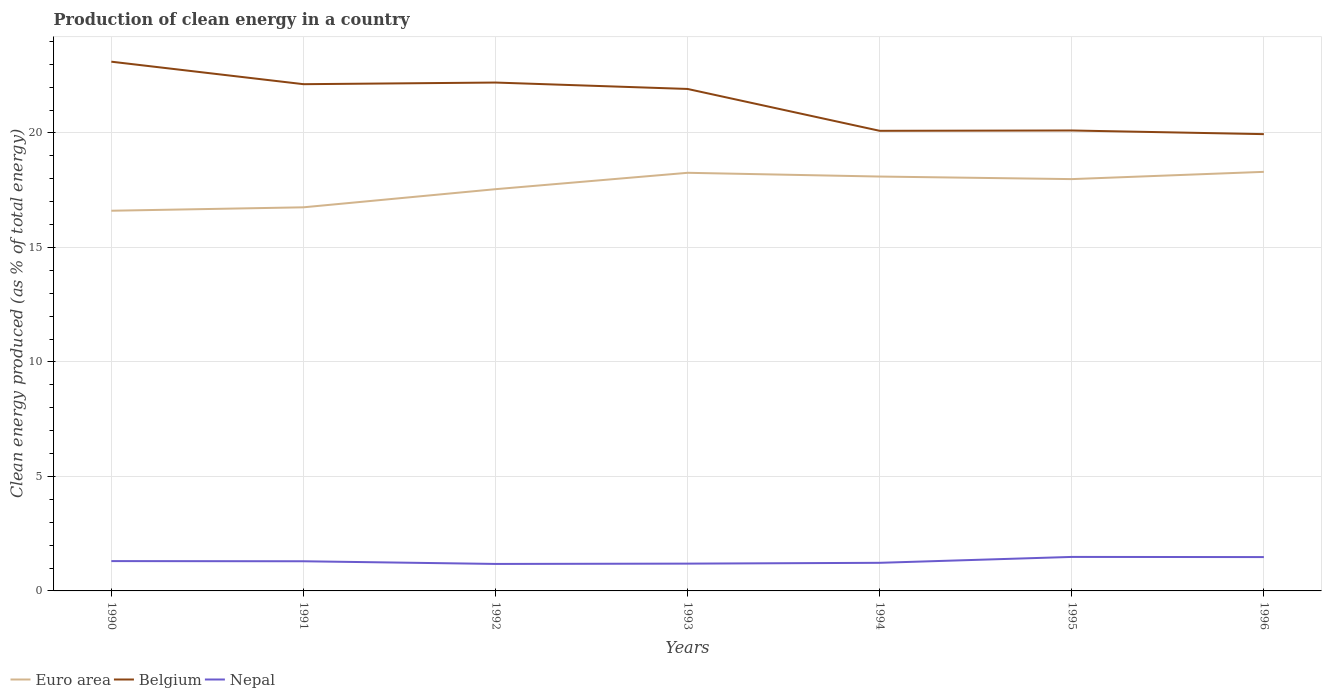Is the number of lines equal to the number of legend labels?
Your answer should be very brief. Yes. Across all years, what is the maximum percentage of clean energy produced in Euro area?
Offer a very short reply. 16.6. What is the total percentage of clean energy produced in Nepal in the graph?
Provide a succinct answer. -0.3. What is the difference between the highest and the second highest percentage of clean energy produced in Belgium?
Offer a very short reply. 3.16. How many years are there in the graph?
Provide a succinct answer. 7. What is the difference between two consecutive major ticks on the Y-axis?
Your answer should be very brief. 5. Does the graph contain grids?
Keep it short and to the point. Yes. Where does the legend appear in the graph?
Ensure brevity in your answer.  Bottom left. How are the legend labels stacked?
Your answer should be compact. Horizontal. What is the title of the graph?
Give a very brief answer. Production of clean energy in a country. What is the label or title of the Y-axis?
Make the answer very short. Clean energy produced (as % of total energy). What is the Clean energy produced (as % of total energy) in Euro area in 1990?
Keep it short and to the point. 16.6. What is the Clean energy produced (as % of total energy) in Belgium in 1990?
Provide a short and direct response. 23.11. What is the Clean energy produced (as % of total energy) in Nepal in 1990?
Offer a terse response. 1.3. What is the Clean energy produced (as % of total energy) in Euro area in 1991?
Keep it short and to the point. 16.75. What is the Clean energy produced (as % of total energy) of Belgium in 1991?
Ensure brevity in your answer.  22.13. What is the Clean energy produced (as % of total energy) of Nepal in 1991?
Provide a short and direct response. 1.3. What is the Clean energy produced (as % of total energy) in Euro area in 1992?
Provide a short and direct response. 17.54. What is the Clean energy produced (as % of total energy) in Belgium in 1992?
Provide a succinct answer. 22.2. What is the Clean energy produced (as % of total energy) in Nepal in 1992?
Keep it short and to the point. 1.18. What is the Clean energy produced (as % of total energy) in Euro area in 1993?
Your response must be concise. 18.26. What is the Clean energy produced (as % of total energy) in Belgium in 1993?
Your answer should be very brief. 21.92. What is the Clean energy produced (as % of total energy) in Nepal in 1993?
Provide a succinct answer. 1.19. What is the Clean energy produced (as % of total energy) in Euro area in 1994?
Make the answer very short. 18.1. What is the Clean energy produced (as % of total energy) of Belgium in 1994?
Your answer should be very brief. 20.09. What is the Clean energy produced (as % of total energy) of Nepal in 1994?
Your response must be concise. 1.23. What is the Clean energy produced (as % of total energy) of Euro area in 1995?
Your answer should be compact. 17.98. What is the Clean energy produced (as % of total energy) of Belgium in 1995?
Offer a very short reply. 20.11. What is the Clean energy produced (as % of total energy) in Nepal in 1995?
Your answer should be compact. 1.49. What is the Clean energy produced (as % of total energy) of Euro area in 1996?
Give a very brief answer. 18.3. What is the Clean energy produced (as % of total energy) of Belgium in 1996?
Offer a very short reply. 19.95. What is the Clean energy produced (as % of total energy) in Nepal in 1996?
Provide a short and direct response. 1.48. Across all years, what is the maximum Clean energy produced (as % of total energy) of Euro area?
Make the answer very short. 18.3. Across all years, what is the maximum Clean energy produced (as % of total energy) in Belgium?
Give a very brief answer. 23.11. Across all years, what is the maximum Clean energy produced (as % of total energy) of Nepal?
Your response must be concise. 1.49. Across all years, what is the minimum Clean energy produced (as % of total energy) of Euro area?
Keep it short and to the point. 16.6. Across all years, what is the minimum Clean energy produced (as % of total energy) of Belgium?
Keep it short and to the point. 19.95. Across all years, what is the minimum Clean energy produced (as % of total energy) in Nepal?
Make the answer very short. 1.18. What is the total Clean energy produced (as % of total energy) in Euro area in the graph?
Keep it short and to the point. 123.54. What is the total Clean energy produced (as % of total energy) in Belgium in the graph?
Ensure brevity in your answer.  149.51. What is the total Clean energy produced (as % of total energy) in Nepal in the graph?
Offer a very short reply. 9.16. What is the difference between the Clean energy produced (as % of total energy) in Euro area in 1990 and that in 1991?
Offer a terse response. -0.15. What is the difference between the Clean energy produced (as % of total energy) in Belgium in 1990 and that in 1991?
Ensure brevity in your answer.  0.98. What is the difference between the Clean energy produced (as % of total energy) of Nepal in 1990 and that in 1991?
Your answer should be very brief. 0.01. What is the difference between the Clean energy produced (as % of total energy) of Euro area in 1990 and that in 1992?
Offer a terse response. -0.94. What is the difference between the Clean energy produced (as % of total energy) in Belgium in 1990 and that in 1992?
Make the answer very short. 0.91. What is the difference between the Clean energy produced (as % of total energy) in Nepal in 1990 and that in 1992?
Your response must be concise. 0.12. What is the difference between the Clean energy produced (as % of total energy) in Euro area in 1990 and that in 1993?
Provide a short and direct response. -1.66. What is the difference between the Clean energy produced (as % of total energy) of Belgium in 1990 and that in 1993?
Offer a very short reply. 1.19. What is the difference between the Clean energy produced (as % of total energy) in Nepal in 1990 and that in 1993?
Your answer should be very brief. 0.11. What is the difference between the Clean energy produced (as % of total energy) of Euro area in 1990 and that in 1994?
Make the answer very short. -1.49. What is the difference between the Clean energy produced (as % of total energy) in Belgium in 1990 and that in 1994?
Your answer should be very brief. 3.02. What is the difference between the Clean energy produced (as % of total energy) of Nepal in 1990 and that in 1994?
Provide a succinct answer. 0.07. What is the difference between the Clean energy produced (as % of total energy) in Euro area in 1990 and that in 1995?
Provide a succinct answer. -1.38. What is the difference between the Clean energy produced (as % of total energy) of Belgium in 1990 and that in 1995?
Keep it short and to the point. 3. What is the difference between the Clean energy produced (as % of total energy) in Nepal in 1990 and that in 1995?
Your answer should be very brief. -0.18. What is the difference between the Clean energy produced (as % of total energy) of Euro area in 1990 and that in 1996?
Give a very brief answer. -1.7. What is the difference between the Clean energy produced (as % of total energy) of Belgium in 1990 and that in 1996?
Ensure brevity in your answer.  3.16. What is the difference between the Clean energy produced (as % of total energy) of Nepal in 1990 and that in 1996?
Ensure brevity in your answer.  -0.17. What is the difference between the Clean energy produced (as % of total energy) of Euro area in 1991 and that in 1992?
Give a very brief answer. -0.79. What is the difference between the Clean energy produced (as % of total energy) in Belgium in 1991 and that in 1992?
Keep it short and to the point. -0.07. What is the difference between the Clean energy produced (as % of total energy) in Nepal in 1991 and that in 1992?
Ensure brevity in your answer.  0.12. What is the difference between the Clean energy produced (as % of total energy) of Euro area in 1991 and that in 1993?
Your response must be concise. -1.51. What is the difference between the Clean energy produced (as % of total energy) in Belgium in 1991 and that in 1993?
Your response must be concise. 0.21. What is the difference between the Clean energy produced (as % of total energy) in Nepal in 1991 and that in 1993?
Provide a succinct answer. 0.1. What is the difference between the Clean energy produced (as % of total energy) in Euro area in 1991 and that in 1994?
Your answer should be compact. -1.34. What is the difference between the Clean energy produced (as % of total energy) in Belgium in 1991 and that in 1994?
Give a very brief answer. 2.04. What is the difference between the Clean energy produced (as % of total energy) in Nepal in 1991 and that in 1994?
Give a very brief answer. 0.07. What is the difference between the Clean energy produced (as % of total energy) in Euro area in 1991 and that in 1995?
Make the answer very short. -1.23. What is the difference between the Clean energy produced (as % of total energy) in Belgium in 1991 and that in 1995?
Keep it short and to the point. 2.02. What is the difference between the Clean energy produced (as % of total energy) of Nepal in 1991 and that in 1995?
Provide a short and direct response. -0.19. What is the difference between the Clean energy produced (as % of total energy) of Euro area in 1991 and that in 1996?
Give a very brief answer. -1.55. What is the difference between the Clean energy produced (as % of total energy) of Belgium in 1991 and that in 1996?
Provide a succinct answer. 2.18. What is the difference between the Clean energy produced (as % of total energy) in Nepal in 1991 and that in 1996?
Give a very brief answer. -0.18. What is the difference between the Clean energy produced (as % of total energy) of Euro area in 1992 and that in 1993?
Offer a very short reply. -0.72. What is the difference between the Clean energy produced (as % of total energy) of Belgium in 1992 and that in 1993?
Offer a terse response. 0.28. What is the difference between the Clean energy produced (as % of total energy) of Nepal in 1992 and that in 1993?
Provide a short and direct response. -0.01. What is the difference between the Clean energy produced (as % of total energy) of Euro area in 1992 and that in 1994?
Offer a terse response. -0.55. What is the difference between the Clean energy produced (as % of total energy) in Belgium in 1992 and that in 1994?
Your answer should be very brief. 2.11. What is the difference between the Clean energy produced (as % of total energy) in Nepal in 1992 and that in 1994?
Your response must be concise. -0.05. What is the difference between the Clean energy produced (as % of total energy) of Euro area in 1992 and that in 1995?
Provide a succinct answer. -0.44. What is the difference between the Clean energy produced (as % of total energy) in Belgium in 1992 and that in 1995?
Ensure brevity in your answer.  2.09. What is the difference between the Clean energy produced (as % of total energy) of Nepal in 1992 and that in 1995?
Offer a very short reply. -0.31. What is the difference between the Clean energy produced (as % of total energy) in Euro area in 1992 and that in 1996?
Give a very brief answer. -0.76. What is the difference between the Clean energy produced (as % of total energy) in Belgium in 1992 and that in 1996?
Offer a very short reply. 2.25. What is the difference between the Clean energy produced (as % of total energy) in Nepal in 1992 and that in 1996?
Provide a succinct answer. -0.3. What is the difference between the Clean energy produced (as % of total energy) in Euro area in 1993 and that in 1994?
Your response must be concise. 0.16. What is the difference between the Clean energy produced (as % of total energy) in Belgium in 1993 and that in 1994?
Your answer should be very brief. 1.83. What is the difference between the Clean energy produced (as % of total energy) of Nepal in 1993 and that in 1994?
Your response must be concise. -0.04. What is the difference between the Clean energy produced (as % of total energy) of Euro area in 1993 and that in 1995?
Your answer should be very brief. 0.28. What is the difference between the Clean energy produced (as % of total energy) in Belgium in 1993 and that in 1995?
Your answer should be compact. 1.81. What is the difference between the Clean energy produced (as % of total energy) of Nepal in 1993 and that in 1995?
Offer a very short reply. -0.29. What is the difference between the Clean energy produced (as % of total energy) in Euro area in 1993 and that in 1996?
Provide a succinct answer. -0.04. What is the difference between the Clean energy produced (as % of total energy) in Belgium in 1993 and that in 1996?
Ensure brevity in your answer.  1.97. What is the difference between the Clean energy produced (as % of total energy) of Nepal in 1993 and that in 1996?
Provide a short and direct response. -0.29. What is the difference between the Clean energy produced (as % of total energy) in Euro area in 1994 and that in 1995?
Ensure brevity in your answer.  0.11. What is the difference between the Clean energy produced (as % of total energy) of Belgium in 1994 and that in 1995?
Offer a terse response. -0.01. What is the difference between the Clean energy produced (as % of total energy) in Nepal in 1994 and that in 1995?
Ensure brevity in your answer.  -0.26. What is the difference between the Clean energy produced (as % of total energy) of Euro area in 1994 and that in 1996?
Keep it short and to the point. -0.21. What is the difference between the Clean energy produced (as % of total energy) in Belgium in 1994 and that in 1996?
Offer a very short reply. 0.14. What is the difference between the Clean energy produced (as % of total energy) of Nepal in 1994 and that in 1996?
Provide a succinct answer. -0.25. What is the difference between the Clean energy produced (as % of total energy) of Euro area in 1995 and that in 1996?
Provide a short and direct response. -0.32. What is the difference between the Clean energy produced (as % of total energy) in Belgium in 1995 and that in 1996?
Give a very brief answer. 0.16. What is the difference between the Clean energy produced (as % of total energy) of Nepal in 1995 and that in 1996?
Your answer should be compact. 0.01. What is the difference between the Clean energy produced (as % of total energy) of Euro area in 1990 and the Clean energy produced (as % of total energy) of Belgium in 1991?
Provide a succinct answer. -5.53. What is the difference between the Clean energy produced (as % of total energy) of Euro area in 1990 and the Clean energy produced (as % of total energy) of Nepal in 1991?
Offer a very short reply. 15.31. What is the difference between the Clean energy produced (as % of total energy) in Belgium in 1990 and the Clean energy produced (as % of total energy) in Nepal in 1991?
Offer a terse response. 21.82. What is the difference between the Clean energy produced (as % of total energy) in Euro area in 1990 and the Clean energy produced (as % of total energy) in Belgium in 1992?
Offer a terse response. -5.6. What is the difference between the Clean energy produced (as % of total energy) in Euro area in 1990 and the Clean energy produced (as % of total energy) in Nepal in 1992?
Your answer should be compact. 15.42. What is the difference between the Clean energy produced (as % of total energy) of Belgium in 1990 and the Clean energy produced (as % of total energy) of Nepal in 1992?
Keep it short and to the point. 21.93. What is the difference between the Clean energy produced (as % of total energy) of Euro area in 1990 and the Clean energy produced (as % of total energy) of Belgium in 1993?
Your answer should be compact. -5.32. What is the difference between the Clean energy produced (as % of total energy) in Euro area in 1990 and the Clean energy produced (as % of total energy) in Nepal in 1993?
Keep it short and to the point. 15.41. What is the difference between the Clean energy produced (as % of total energy) of Belgium in 1990 and the Clean energy produced (as % of total energy) of Nepal in 1993?
Ensure brevity in your answer.  21.92. What is the difference between the Clean energy produced (as % of total energy) of Euro area in 1990 and the Clean energy produced (as % of total energy) of Belgium in 1994?
Keep it short and to the point. -3.49. What is the difference between the Clean energy produced (as % of total energy) of Euro area in 1990 and the Clean energy produced (as % of total energy) of Nepal in 1994?
Offer a terse response. 15.38. What is the difference between the Clean energy produced (as % of total energy) of Belgium in 1990 and the Clean energy produced (as % of total energy) of Nepal in 1994?
Keep it short and to the point. 21.88. What is the difference between the Clean energy produced (as % of total energy) of Euro area in 1990 and the Clean energy produced (as % of total energy) of Belgium in 1995?
Give a very brief answer. -3.5. What is the difference between the Clean energy produced (as % of total energy) of Euro area in 1990 and the Clean energy produced (as % of total energy) of Nepal in 1995?
Ensure brevity in your answer.  15.12. What is the difference between the Clean energy produced (as % of total energy) of Belgium in 1990 and the Clean energy produced (as % of total energy) of Nepal in 1995?
Ensure brevity in your answer.  21.63. What is the difference between the Clean energy produced (as % of total energy) of Euro area in 1990 and the Clean energy produced (as % of total energy) of Belgium in 1996?
Provide a succinct answer. -3.34. What is the difference between the Clean energy produced (as % of total energy) in Euro area in 1990 and the Clean energy produced (as % of total energy) in Nepal in 1996?
Provide a succinct answer. 15.13. What is the difference between the Clean energy produced (as % of total energy) in Belgium in 1990 and the Clean energy produced (as % of total energy) in Nepal in 1996?
Give a very brief answer. 21.63. What is the difference between the Clean energy produced (as % of total energy) in Euro area in 1991 and the Clean energy produced (as % of total energy) in Belgium in 1992?
Make the answer very short. -5.45. What is the difference between the Clean energy produced (as % of total energy) of Euro area in 1991 and the Clean energy produced (as % of total energy) of Nepal in 1992?
Ensure brevity in your answer.  15.57. What is the difference between the Clean energy produced (as % of total energy) of Belgium in 1991 and the Clean energy produced (as % of total energy) of Nepal in 1992?
Provide a short and direct response. 20.95. What is the difference between the Clean energy produced (as % of total energy) of Euro area in 1991 and the Clean energy produced (as % of total energy) of Belgium in 1993?
Your answer should be compact. -5.17. What is the difference between the Clean energy produced (as % of total energy) in Euro area in 1991 and the Clean energy produced (as % of total energy) in Nepal in 1993?
Give a very brief answer. 15.56. What is the difference between the Clean energy produced (as % of total energy) in Belgium in 1991 and the Clean energy produced (as % of total energy) in Nepal in 1993?
Offer a terse response. 20.94. What is the difference between the Clean energy produced (as % of total energy) of Euro area in 1991 and the Clean energy produced (as % of total energy) of Belgium in 1994?
Your answer should be very brief. -3.34. What is the difference between the Clean energy produced (as % of total energy) of Euro area in 1991 and the Clean energy produced (as % of total energy) of Nepal in 1994?
Make the answer very short. 15.52. What is the difference between the Clean energy produced (as % of total energy) in Belgium in 1991 and the Clean energy produced (as % of total energy) in Nepal in 1994?
Provide a short and direct response. 20.9. What is the difference between the Clean energy produced (as % of total energy) of Euro area in 1991 and the Clean energy produced (as % of total energy) of Belgium in 1995?
Provide a short and direct response. -3.36. What is the difference between the Clean energy produced (as % of total energy) of Euro area in 1991 and the Clean energy produced (as % of total energy) of Nepal in 1995?
Your answer should be compact. 15.27. What is the difference between the Clean energy produced (as % of total energy) in Belgium in 1991 and the Clean energy produced (as % of total energy) in Nepal in 1995?
Your answer should be very brief. 20.64. What is the difference between the Clean energy produced (as % of total energy) in Euro area in 1991 and the Clean energy produced (as % of total energy) in Belgium in 1996?
Make the answer very short. -3.2. What is the difference between the Clean energy produced (as % of total energy) in Euro area in 1991 and the Clean energy produced (as % of total energy) in Nepal in 1996?
Give a very brief answer. 15.27. What is the difference between the Clean energy produced (as % of total energy) in Belgium in 1991 and the Clean energy produced (as % of total energy) in Nepal in 1996?
Provide a short and direct response. 20.65. What is the difference between the Clean energy produced (as % of total energy) of Euro area in 1992 and the Clean energy produced (as % of total energy) of Belgium in 1993?
Offer a very short reply. -4.38. What is the difference between the Clean energy produced (as % of total energy) of Euro area in 1992 and the Clean energy produced (as % of total energy) of Nepal in 1993?
Ensure brevity in your answer.  16.35. What is the difference between the Clean energy produced (as % of total energy) in Belgium in 1992 and the Clean energy produced (as % of total energy) in Nepal in 1993?
Provide a short and direct response. 21.01. What is the difference between the Clean energy produced (as % of total energy) of Euro area in 1992 and the Clean energy produced (as % of total energy) of Belgium in 1994?
Provide a short and direct response. -2.55. What is the difference between the Clean energy produced (as % of total energy) of Euro area in 1992 and the Clean energy produced (as % of total energy) of Nepal in 1994?
Your answer should be very brief. 16.32. What is the difference between the Clean energy produced (as % of total energy) in Belgium in 1992 and the Clean energy produced (as % of total energy) in Nepal in 1994?
Ensure brevity in your answer.  20.97. What is the difference between the Clean energy produced (as % of total energy) in Euro area in 1992 and the Clean energy produced (as % of total energy) in Belgium in 1995?
Your answer should be very brief. -2.56. What is the difference between the Clean energy produced (as % of total energy) of Euro area in 1992 and the Clean energy produced (as % of total energy) of Nepal in 1995?
Give a very brief answer. 16.06. What is the difference between the Clean energy produced (as % of total energy) in Belgium in 1992 and the Clean energy produced (as % of total energy) in Nepal in 1995?
Provide a short and direct response. 20.72. What is the difference between the Clean energy produced (as % of total energy) in Euro area in 1992 and the Clean energy produced (as % of total energy) in Belgium in 1996?
Provide a short and direct response. -2.4. What is the difference between the Clean energy produced (as % of total energy) in Euro area in 1992 and the Clean energy produced (as % of total energy) in Nepal in 1996?
Your answer should be very brief. 16.07. What is the difference between the Clean energy produced (as % of total energy) in Belgium in 1992 and the Clean energy produced (as % of total energy) in Nepal in 1996?
Ensure brevity in your answer.  20.72. What is the difference between the Clean energy produced (as % of total energy) of Euro area in 1993 and the Clean energy produced (as % of total energy) of Belgium in 1994?
Give a very brief answer. -1.83. What is the difference between the Clean energy produced (as % of total energy) of Euro area in 1993 and the Clean energy produced (as % of total energy) of Nepal in 1994?
Your answer should be very brief. 17.03. What is the difference between the Clean energy produced (as % of total energy) in Belgium in 1993 and the Clean energy produced (as % of total energy) in Nepal in 1994?
Your answer should be compact. 20.69. What is the difference between the Clean energy produced (as % of total energy) in Euro area in 1993 and the Clean energy produced (as % of total energy) in Belgium in 1995?
Ensure brevity in your answer.  -1.85. What is the difference between the Clean energy produced (as % of total energy) in Euro area in 1993 and the Clean energy produced (as % of total energy) in Nepal in 1995?
Provide a succinct answer. 16.77. What is the difference between the Clean energy produced (as % of total energy) in Belgium in 1993 and the Clean energy produced (as % of total energy) in Nepal in 1995?
Offer a terse response. 20.44. What is the difference between the Clean energy produced (as % of total energy) in Euro area in 1993 and the Clean energy produced (as % of total energy) in Belgium in 1996?
Your response must be concise. -1.69. What is the difference between the Clean energy produced (as % of total energy) in Euro area in 1993 and the Clean energy produced (as % of total energy) in Nepal in 1996?
Make the answer very short. 16.78. What is the difference between the Clean energy produced (as % of total energy) in Belgium in 1993 and the Clean energy produced (as % of total energy) in Nepal in 1996?
Provide a short and direct response. 20.44. What is the difference between the Clean energy produced (as % of total energy) of Euro area in 1994 and the Clean energy produced (as % of total energy) of Belgium in 1995?
Ensure brevity in your answer.  -2.01. What is the difference between the Clean energy produced (as % of total energy) in Euro area in 1994 and the Clean energy produced (as % of total energy) in Nepal in 1995?
Keep it short and to the point. 16.61. What is the difference between the Clean energy produced (as % of total energy) of Belgium in 1994 and the Clean energy produced (as % of total energy) of Nepal in 1995?
Provide a succinct answer. 18.61. What is the difference between the Clean energy produced (as % of total energy) in Euro area in 1994 and the Clean energy produced (as % of total energy) in Belgium in 1996?
Your answer should be compact. -1.85. What is the difference between the Clean energy produced (as % of total energy) in Euro area in 1994 and the Clean energy produced (as % of total energy) in Nepal in 1996?
Offer a very short reply. 16.62. What is the difference between the Clean energy produced (as % of total energy) in Belgium in 1994 and the Clean energy produced (as % of total energy) in Nepal in 1996?
Offer a very short reply. 18.62. What is the difference between the Clean energy produced (as % of total energy) in Euro area in 1995 and the Clean energy produced (as % of total energy) in Belgium in 1996?
Give a very brief answer. -1.96. What is the difference between the Clean energy produced (as % of total energy) of Euro area in 1995 and the Clean energy produced (as % of total energy) of Nepal in 1996?
Provide a short and direct response. 16.51. What is the difference between the Clean energy produced (as % of total energy) of Belgium in 1995 and the Clean energy produced (as % of total energy) of Nepal in 1996?
Your answer should be very brief. 18.63. What is the average Clean energy produced (as % of total energy) of Euro area per year?
Your response must be concise. 17.65. What is the average Clean energy produced (as % of total energy) in Belgium per year?
Give a very brief answer. 21.36. What is the average Clean energy produced (as % of total energy) in Nepal per year?
Offer a terse response. 1.31. In the year 1990, what is the difference between the Clean energy produced (as % of total energy) of Euro area and Clean energy produced (as % of total energy) of Belgium?
Your answer should be compact. -6.51. In the year 1990, what is the difference between the Clean energy produced (as % of total energy) in Euro area and Clean energy produced (as % of total energy) in Nepal?
Make the answer very short. 15.3. In the year 1990, what is the difference between the Clean energy produced (as % of total energy) in Belgium and Clean energy produced (as % of total energy) in Nepal?
Offer a terse response. 21.81. In the year 1991, what is the difference between the Clean energy produced (as % of total energy) in Euro area and Clean energy produced (as % of total energy) in Belgium?
Give a very brief answer. -5.38. In the year 1991, what is the difference between the Clean energy produced (as % of total energy) in Euro area and Clean energy produced (as % of total energy) in Nepal?
Provide a short and direct response. 15.46. In the year 1991, what is the difference between the Clean energy produced (as % of total energy) of Belgium and Clean energy produced (as % of total energy) of Nepal?
Provide a succinct answer. 20.83. In the year 1992, what is the difference between the Clean energy produced (as % of total energy) in Euro area and Clean energy produced (as % of total energy) in Belgium?
Provide a succinct answer. -4.66. In the year 1992, what is the difference between the Clean energy produced (as % of total energy) of Euro area and Clean energy produced (as % of total energy) of Nepal?
Keep it short and to the point. 16.37. In the year 1992, what is the difference between the Clean energy produced (as % of total energy) of Belgium and Clean energy produced (as % of total energy) of Nepal?
Provide a succinct answer. 21.02. In the year 1993, what is the difference between the Clean energy produced (as % of total energy) of Euro area and Clean energy produced (as % of total energy) of Belgium?
Offer a terse response. -3.66. In the year 1993, what is the difference between the Clean energy produced (as % of total energy) in Euro area and Clean energy produced (as % of total energy) in Nepal?
Offer a very short reply. 17.07. In the year 1993, what is the difference between the Clean energy produced (as % of total energy) in Belgium and Clean energy produced (as % of total energy) in Nepal?
Offer a very short reply. 20.73. In the year 1994, what is the difference between the Clean energy produced (as % of total energy) of Euro area and Clean energy produced (as % of total energy) of Belgium?
Make the answer very short. -2. In the year 1994, what is the difference between the Clean energy produced (as % of total energy) of Euro area and Clean energy produced (as % of total energy) of Nepal?
Ensure brevity in your answer.  16.87. In the year 1994, what is the difference between the Clean energy produced (as % of total energy) in Belgium and Clean energy produced (as % of total energy) in Nepal?
Offer a very short reply. 18.87. In the year 1995, what is the difference between the Clean energy produced (as % of total energy) of Euro area and Clean energy produced (as % of total energy) of Belgium?
Keep it short and to the point. -2.12. In the year 1995, what is the difference between the Clean energy produced (as % of total energy) of Euro area and Clean energy produced (as % of total energy) of Nepal?
Provide a short and direct response. 16.5. In the year 1995, what is the difference between the Clean energy produced (as % of total energy) of Belgium and Clean energy produced (as % of total energy) of Nepal?
Give a very brief answer. 18.62. In the year 1996, what is the difference between the Clean energy produced (as % of total energy) of Euro area and Clean energy produced (as % of total energy) of Belgium?
Make the answer very short. -1.65. In the year 1996, what is the difference between the Clean energy produced (as % of total energy) of Euro area and Clean energy produced (as % of total energy) of Nepal?
Provide a succinct answer. 16.82. In the year 1996, what is the difference between the Clean energy produced (as % of total energy) of Belgium and Clean energy produced (as % of total energy) of Nepal?
Offer a terse response. 18.47. What is the ratio of the Clean energy produced (as % of total energy) in Euro area in 1990 to that in 1991?
Offer a very short reply. 0.99. What is the ratio of the Clean energy produced (as % of total energy) in Belgium in 1990 to that in 1991?
Ensure brevity in your answer.  1.04. What is the ratio of the Clean energy produced (as % of total energy) in Nepal in 1990 to that in 1991?
Provide a short and direct response. 1.01. What is the ratio of the Clean energy produced (as % of total energy) in Euro area in 1990 to that in 1992?
Offer a terse response. 0.95. What is the ratio of the Clean energy produced (as % of total energy) of Belgium in 1990 to that in 1992?
Keep it short and to the point. 1.04. What is the ratio of the Clean energy produced (as % of total energy) in Nepal in 1990 to that in 1992?
Make the answer very short. 1.11. What is the ratio of the Clean energy produced (as % of total energy) of Euro area in 1990 to that in 1993?
Your answer should be very brief. 0.91. What is the ratio of the Clean energy produced (as % of total energy) of Belgium in 1990 to that in 1993?
Provide a succinct answer. 1.05. What is the ratio of the Clean energy produced (as % of total energy) of Nepal in 1990 to that in 1993?
Keep it short and to the point. 1.09. What is the ratio of the Clean energy produced (as % of total energy) of Euro area in 1990 to that in 1994?
Offer a terse response. 0.92. What is the ratio of the Clean energy produced (as % of total energy) of Belgium in 1990 to that in 1994?
Offer a very short reply. 1.15. What is the ratio of the Clean energy produced (as % of total energy) in Nepal in 1990 to that in 1994?
Your response must be concise. 1.06. What is the ratio of the Clean energy produced (as % of total energy) of Euro area in 1990 to that in 1995?
Provide a short and direct response. 0.92. What is the ratio of the Clean energy produced (as % of total energy) in Belgium in 1990 to that in 1995?
Give a very brief answer. 1.15. What is the ratio of the Clean energy produced (as % of total energy) of Nepal in 1990 to that in 1995?
Provide a succinct answer. 0.88. What is the ratio of the Clean energy produced (as % of total energy) in Euro area in 1990 to that in 1996?
Keep it short and to the point. 0.91. What is the ratio of the Clean energy produced (as % of total energy) in Belgium in 1990 to that in 1996?
Provide a short and direct response. 1.16. What is the ratio of the Clean energy produced (as % of total energy) in Nepal in 1990 to that in 1996?
Provide a succinct answer. 0.88. What is the ratio of the Clean energy produced (as % of total energy) of Euro area in 1991 to that in 1992?
Offer a terse response. 0.95. What is the ratio of the Clean energy produced (as % of total energy) of Nepal in 1991 to that in 1992?
Offer a very short reply. 1.1. What is the ratio of the Clean energy produced (as % of total energy) of Euro area in 1991 to that in 1993?
Your response must be concise. 0.92. What is the ratio of the Clean energy produced (as % of total energy) of Belgium in 1991 to that in 1993?
Ensure brevity in your answer.  1.01. What is the ratio of the Clean energy produced (as % of total energy) of Nepal in 1991 to that in 1993?
Provide a short and direct response. 1.09. What is the ratio of the Clean energy produced (as % of total energy) of Euro area in 1991 to that in 1994?
Your answer should be very brief. 0.93. What is the ratio of the Clean energy produced (as % of total energy) of Belgium in 1991 to that in 1994?
Your answer should be compact. 1.1. What is the ratio of the Clean energy produced (as % of total energy) in Nepal in 1991 to that in 1994?
Make the answer very short. 1.05. What is the ratio of the Clean energy produced (as % of total energy) of Euro area in 1991 to that in 1995?
Keep it short and to the point. 0.93. What is the ratio of the Clean energy produced (as % of total energy) in Belgium in 1991 to that in 1995?
Make the answer very short. 1.1. What is the ratio of the Clean energy produced (as % of total energy) in Nepal in 1991 to that in 1995?
Keep it short and to the point. 0.87. What is the ratio of the Clean energy produced (as % of total energy) of Euro area in 1991 to that in 1996?
Make the answer very short. 0.92. What is the ratio of the Clean energy produced (as % of total energy) of Belgium in 1991 to that in 1996?
Ensure brevity in your answer.  1.11. What is the ratio of the Clean energy produced (as % of total energy) of Nepal in 1991 to that in 1996?
Your answer should be compact. 0.88. What is the ratio of the Clean energy produced (as % of total energy) of Euro area in 1992 to that in 1993?
Your response must be concise. 0.96. What is the ratio of the Clean energy produced (as % of total energy) in Belgium in 1992 to that in 1993?
Offer a terse response. 1.01. What is the ratio of the Clean energy produced (as % of total energy) in Nepal in 1992 to that in 1993?
Your answer should be very brief. 0.99. What is the ratio of the Clean energy produced (as % of total energy) of Euro area in 1992 to that in 1994?
Keep it short and to the point. 0.97. What is the ratio of the Clean energy produced (as % of total energy) of Belgium in 1992 to that in 1994?
Your answer should be very brief. 1.1. What is the ratio of the Clean energy produced (as % of total energy) in Nepal in 1992 to that in 1994?
Make the answer very short. 0.96. What is the ratio of the Clean energy produced (as % of total energy) in Euro area in 1992 to that in 1995?
Provide a succinct answer. 0.98. What is the ratio of the Clean energy produced (as % of total energy) of Belgium in 1992 to that in 1995?
Keep it short and to the point. 1.1. What is the ratio of the Clean energy produced (as % of total energy) of Nepal in 1992 to that in 1995?
Offer a very short reply. 0.79. What is the ratio of the Clean energy produced (as % of total energy) in Euro area in 1992 to that in 1996?
Your answer should be compact. 0.96. What is the ratio of the Clean energy produced (as % of total energy) of Belgium in 1992 to that in 1996?
Your answer should be compact. 1.11. What is the ratio of the Clean energy produced (as % of total energy) in Nepal in 1992 to that in 1996?
Offer a terse response. 0.8. What is the ratio of the Clean energy produced (as % of total energy) of Euro area in 1993 to that in 1994?
Offer a very short reply. 1.01. What is the ratio of the Clean energy produced (as % of total energy) of Belgium in 1993 to that in 1994?
Offer a very short reply. 1.09. What is the ratio of the Clean energy produced (as % of total energy) in Nepal in 1993 to that in 1994?
Provide a succinct answer. 0.97. What is the ratio of the Clean energy produced (as % of total energy) in Euro area in 1993 to that in 1995?
Provide a succinct answer. 1.02. What is the ratio of the Clean energy produced (as % of total energy) in Belgium in 1993 to that in 1995?
Make the answer very short. 1.09. What is the ratio of the Clean energy produced (as % of total energy) in Nepal in 1993 to that in 1995?
Provide a succinct answer. 0.8. What is the ratio of the Clean energy produced (as % of total energy) in Euro area in 1993 to that in 1996?
Your response must be concise. 1. What is the ratio of the Clean energy produced (as % of total energy) in Belgium in 1993 to that in 1996?
Offer a very short reply. 1.1. What is the ratio of the Clean energy produced (as % of total energy) in Nepal in 1993 to that in 1996?
Your answer should be compact. 0.81. What is the ratio of the Clean energy produced (as % of total energy) of Euro area in 1994 to that in 1995?
Give a very brief answer. 1.01. What is the ratio of the Clean energy produced (as % of total energy) in Nepal in 1994 to that in 1995?
Your answer should be compact. 0.83. What is the ratio of the Clean energy produced (as % of total energy) of Belgium in 1994 to that in 1996?
Ensure brevity in your answer.  1.01. What is the ratio of the Clean energy produced (as % of total energy) in Nepal in 1994 to that in 1996?
Provide a succinct answer. 0.83. What is the ratio of the Clean energy produced (as % of total energy) of Euro area in 1995 to that in 1996?
Offer a terse response. 0.98. What is the ratio of the Clean energy produced (as % of total energy) in Nepal in 1995 to that in 1996?
Offer a very short reply. 1. What is the difference between the highest and the second highest Clean energy produced (as % of total energy) in Euro area?
Keep it short and to the point. 0.04. What is the difference between the highest and the second highest Clean energy produced (as % of total energy) in Belgium?
Keep it short and to the point. 0.91. What is the difference between the highest and the second highest Clean energy produced (as % of total energy) in Nepal?
Provide a short and direct response. 0.01. What is the difference between the highest and the lowest Clean energy produced (as % of total energy) of Euro area?
Offer a very short reply. 1.7. What is the difference between the highest and the lowest Clean energy produced (as % of total energy) in Belgium?
Your response must be concise. 3.16. What is the difference between the highest and the lowest Clean energy produced (as % of total energy) in Nepal?
Your answer should be compact. 0.31. 